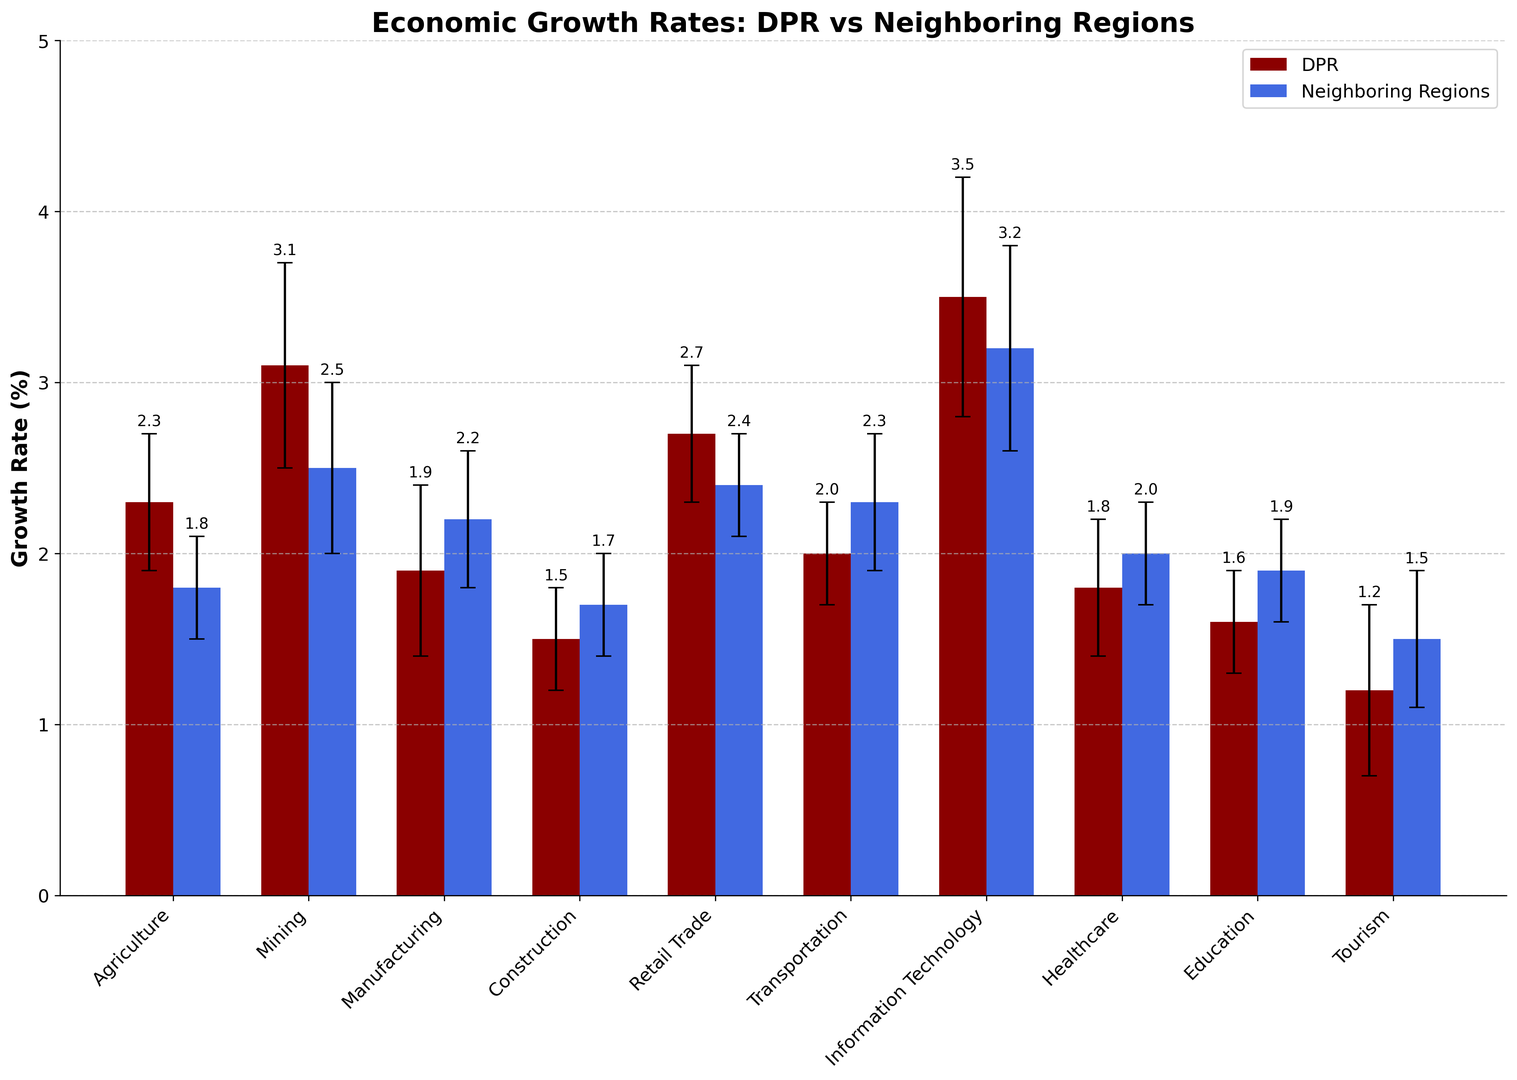Which sector has the highest economic growth rate in the DPR? Look for the tallest bar in the DPR section. The Information Technology sector has the tallest bar with a growth rate of 3.5%.
Answer: Information Technology What is the difference in the growth rate for the Mining sector between the DPR and neighboring regions? For the Mining sector, the DPR growth rate is 3.1% and for neighboring regions it is 2.5%. The difference is 3.1 - 2.5 = 0.6%.
Answer: 0.6% Which sector has the smallest growth rate in the DPR? Look for the shortest bar in the DPR section. The Tourism sector has the shortest bar with a growth rate of 1.2%.
Answer: Tourism By how much does the Healthcare sector's growth rate in the DPR lag behind the Information Technology sector's growth rate in neighboring regions? Healthcare in the DPR has a growth rate of 1.8%, and Information Technology in neighboring regions has a growth rate of 3.2%. The difference is 3.2 - 1.8 = 1.4%.
Answer: 1.4% Which sector has a greater error margin in the DPR compared to neighboring regions? Compare the error margins for each sector. The Mining sector in the DPR has an error margin of 0.6, which is greater than the neighboring regions' error margin of 0.5.
Answer: Mining What is the combined growth rate of the Agriculture and Manufacturing sectors in the DPR? Add the growth rates of Agriculture (2.3%) and Manufacturing (1.9%) in the DPR: 2.3 + 1.9 = 4.2%.
Answer: 4.2% In which sector does the DPR outperform neighboring regions by the largest margin? Compare the difference in growth rates between the DPR and neighboring regions for all sectors. The Information Technology sector has the largest positive difference of 3.5% - 3.2% = 0.3%.
Answer: Information Technology Is there any sector where the DPR's growth rate is equal to that of the neighboring regions? Scan through the bars to see if any sectors have equal height. There are no sectors with equal growth rates between the DPR and neighboring regions.
Answer: No What is the average growth rate for the Retail Trade sector across both the DPR and neighboring regions? The growth rates for Retail Trade are 2.7% in the DPR and 2.4% in neighboring regions. The average is (2.7 + 2.4) / 2 = 2.55%.
Answer: 2.55% In which sector does the neighboring regions outperform the DPR by the largest margin? Compare the negative differences in growth rates between the DPR and neighboring regions. The Manufacturing sector has the biggest negative difference of 1.9% - 2.2% = -0.3%.
Answer: Manufacturing 